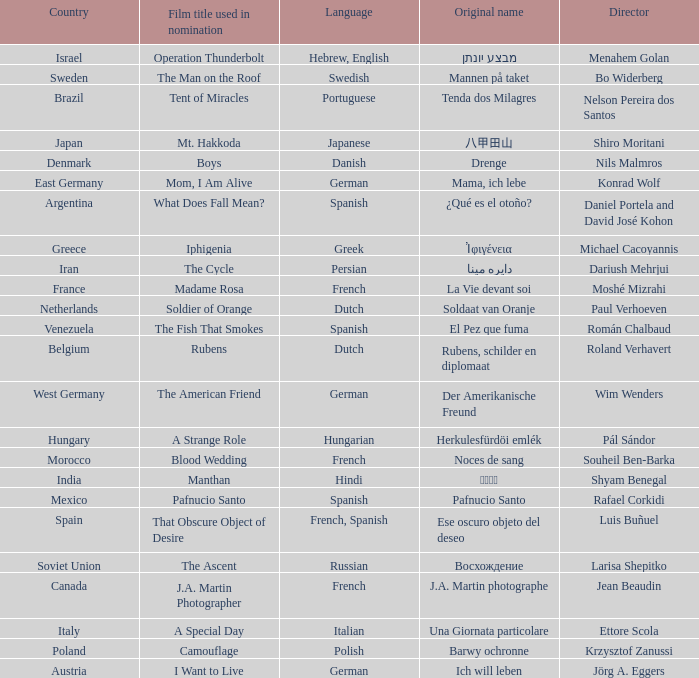Which country is the film Tent of Miracles from? Brazil. 